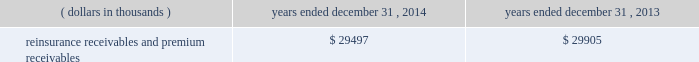Investments .
Fixed maturity and equity security investments available for sale , at market value , reflect unrealized appreciation and depreciation , as a result of temporary changes in market value during the period , in shareholders 2019 equity , net of income taxes in 201caccumulated other comprehensive income ( loss ) 201d in the consolidated balance sheets .
Fixed maturity and equity securities carried at fair value reflect fair value re- measurements as net realized capital gains and losses in the consolidated statements of operations and comprehensive income ( loss ) .
The company records changes in fair value for its fixed maturities available for sale , at market value through shareholders 2019 equity , net of taxes in accumulated other comprehensive income ( loss ) since cash flows from these investments will be primarily used to settle its reserve for losses and loss adjustment expense liabilities .
The company anticipates holding these investments for an extended period as the cash flow from interest and maturities will fund the projected payout of these liabilities .
Fixed maturities carried at fair value represent a portfolio of convertible bond securities , which have characteristics similar to equity securities and at times , designated foreign denominated fixed maturity securities , which will be used to settle loss and loss adjustment reserves in the same currency .
The company carries all of its equity securities at fair value except for mutual fund investments whose underlying investments are comprised of fixed maturity securities .
For equity securities , available for sale , at fair value , the company reflects changes in value as net realized capital gains and losses since these securities may be sold in the near term depending on financial market conditions .
Interest income on all fixed maturities and dividend income on all equity securities are included as part of net investment income in the consolidated statements of operations and comprehensive income ( loss ) .
Unrealized losses on fixed maturities , which are deemed other-than-temporary and related to the credit quality of a security , are charged to net income ( loss ) as net realized capital losses .
Short-term investments are stated at cost , which approximates market value .
Realized gains or losses on sales of investments are determined on the basis of identified cost .
For non- publicly traded securities , market prices are determined through the use of pricing models that evaluate securities relative to the u.s .
Treasury yield curve , taking into account the issue type , credit quality , and cash flow characteristics of each security .
For publicly traded securities , market value is based on quoted market prices or valuation models that use observable market inputs .
When a sector of the financial markets is inactive or illiquid , the company may use its own assumptions about future cash flows and risk-adjusted discount rates to determine fair value .
Retrospective adjustments are employed to recalculate the values of asset-backed securities .
Each acquisition lot is reviewed to recalculate the effective yield .
The recalculated effective yield is used to derive a book value as if the new yield were applied at the time of acquisition .
Outstanding principal factors from the time of acquisition to the adjustment date are used to calculate the prepayment history for all applicable securities .
Conditional prepayment rates , computed with life to date factor histories and weighted average maturities , are used to effect the calculation of projected and prepayments for pass-through security types .
Other invested assets include limited partnerships and rabbi trusts .
Limited partnerships are accounted for under the equity method of accounting , which can be recorded on a monthly or quarterly lag .
Uncollectible receivable balances .
The company provides reserves for uncollectible reinsurance recoverable and premium receivable balances based on management 2019s assessment of the collectability of the outstanding balances .
Such reserves are presented in the table below for the periods indicated. .

What is the percentage change in the balance of reinsurance receivables and premium receivables from 2013 to 2014? 
Computations: ((29497 - 29905) / 29905)
Answer: -0.01364. 